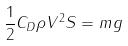Convert formula to latex. <formula><loc_0><loc_0><loc_500><loc_500>\frac { 1 } { 2 } C _ { D } \rho V ^ { 2 } S = m g</formula> 